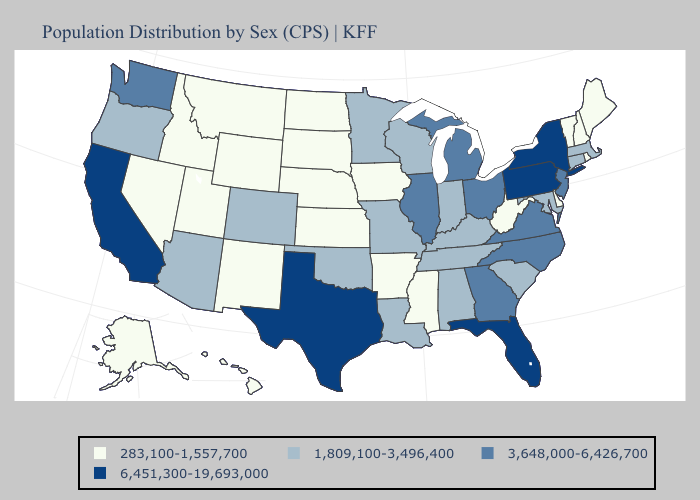Does North Dakota have the lowest value in the MidWest?
Write a very short answer. Yes. Does Texas have the highest value in the South?
Quick response, please. Yes. Does Georgia have the highest value in the South?
Quick response, please. No. Does Delaware have the lowest value in the South?
Keep it brief. Yes. Does the first symbol in the legend represent the smallest category?
Give a very brief answer. Yes. Which states have the lowest value in the Northeast?
Be succinct. Maine, New Hampshire, Rhode Island, Vermont. What is the highest value in the Northeast ?
Be succinct. 6,451,300-19,693,000. What is the highest value in the USA?
Concise answer only. 6,451,300-19,693,000. Does California have the highest value in the West?
Concise answer only. Yes. Does the first symbol in the legend represent the smallest category?
Answer briefly. Yes. What is the lowest value in the USA?
Short answer required. 283,100-1,557,700. What is the value of Oklahoma?
Short answer required. 1,809,100-3,496,400. Name the states that have a value in the range 3,648,000-6,426,700?
Concise answer only. Georgia, Illinois, Michigan, New Jersey, North Carolina, Ohio, Virginia, Washington. How many symbols are there in the legend?
Give a very brief answer. 4. Which states have the lowest value in the MidWest?
Quick response, please. Iowa, Kansas, Nebraska, North Dakota, South Dakota. 